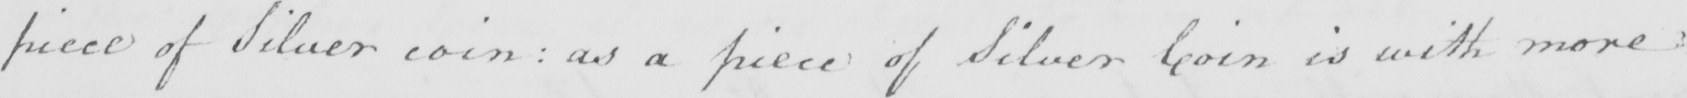Please provide the text content of this handwritten line. piece of Silver coin :  as a piece of Silver Coin is with more 